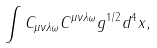Convert formula to latex. <formula><loc_0><loc_0><loc_500><loc_500>\int { C _ { \mu \nu \lambda \omega } C ^ { \mu \nu \lambda \omega } g ^ { 1 / 2 } d ^ { 4 } x } ,</formula> 